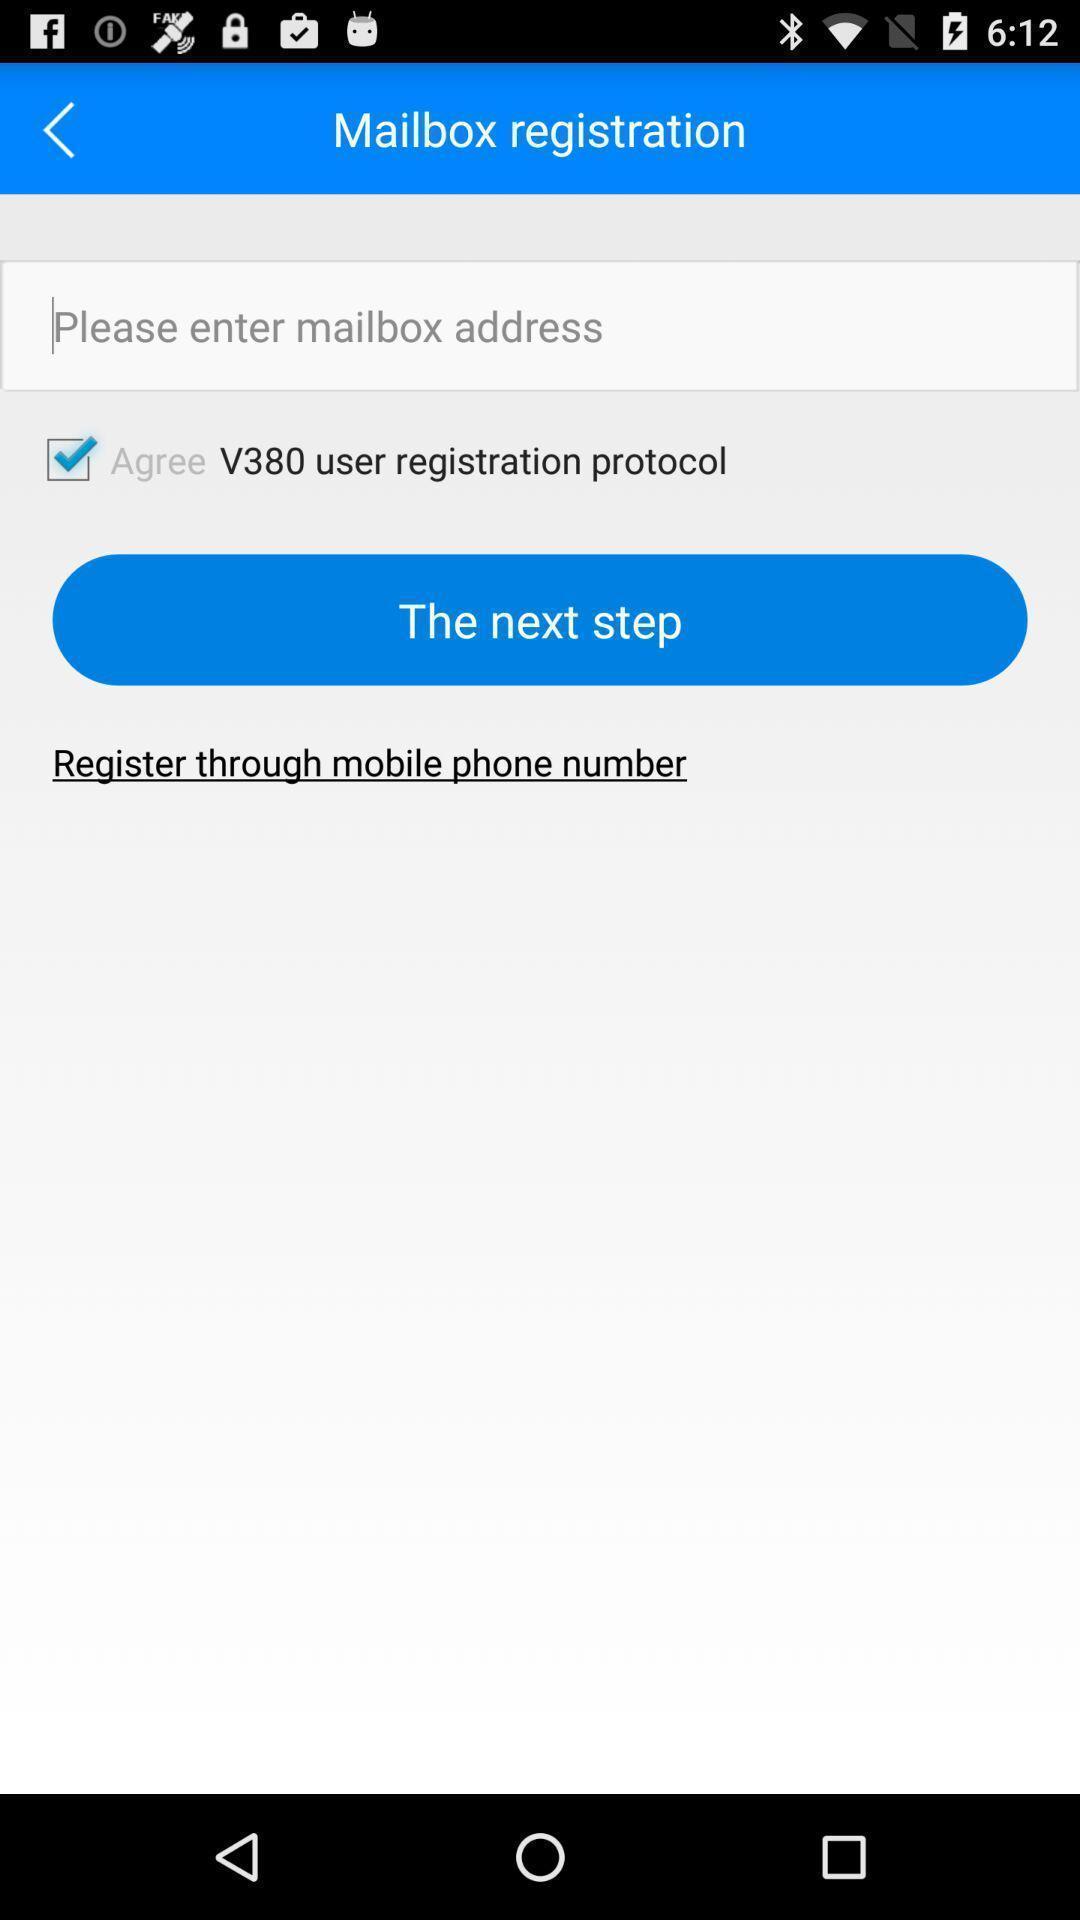Provide a description of this screenshot. Screen shows registration. 